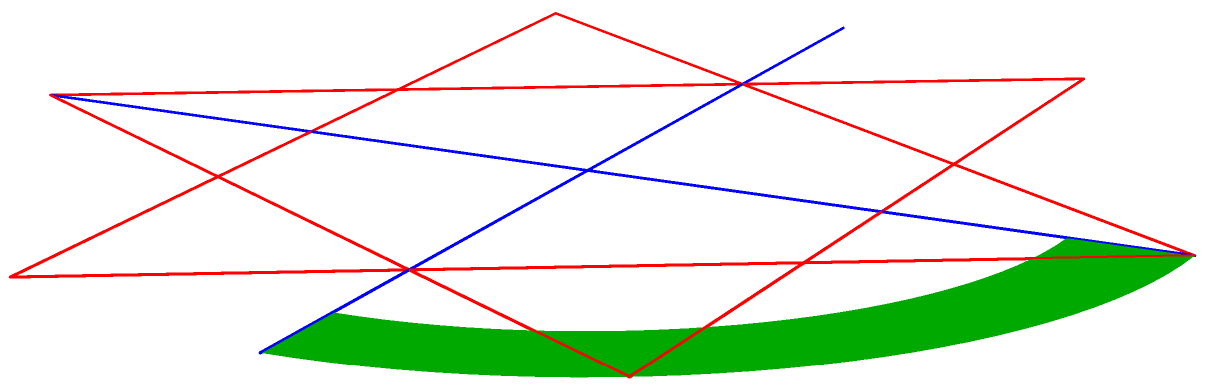In the 3D representation shown, three religious symbols are depicted: a Christian cross (blue), an Islamic crescent (green), and a Jewish Star of David (red). If all symbols were to be rotated 90 degrees around the vertical axis, which symbol would appear to have the smallest width when viewed from the original perspective? To solve this problem, we need to consider how each symbol would appear after a 90-degree rotation around the vertical axis:

1. The Christian cross:
   - Currently, it has full width along the horizontal axis.
   - After rotation, its width would be reduced to the thickness of the vertical beam.

2. The Islamic crescent:
   - Currently, it shows its curved profile.
   - After rotation, it would present its edge, appearing as a thin, vertical line.

3. The Star of David:
   - Currently, it shows its full width.
   - After rotation, it would still present a significant width due to its three-dimensional structure.

Comparing these:
- The cross would become very thin, but still have some visible width.
- The crescent would appear as the thinnest, essentially a line when viewed edge-on.
- The Star of David would maintain the most width of the three.

Therefore, the Islamic crescent would appear to have the smallest width after rotation.
Answer: Islamic crescent 